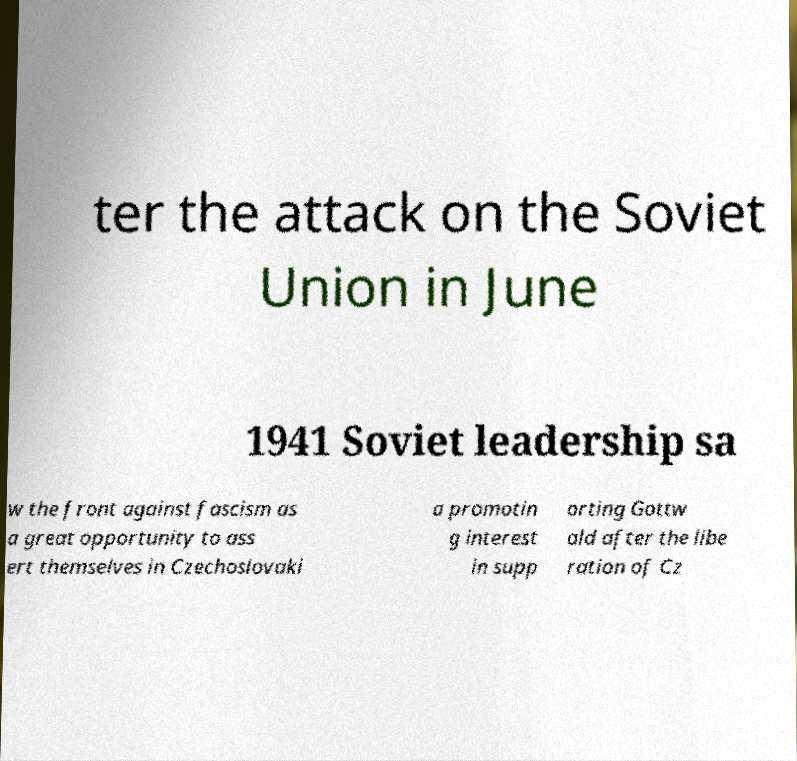Please read and relay the text visible in this image. What does it say? ter the attack on the Soviet Union in June 1941 Soviet leadership sa w the front against fascism as a great opportunity to ass ert themselves in Czechoslovaki a promotin g interest in supp orting Gottw ald after the libe ration of Cz 